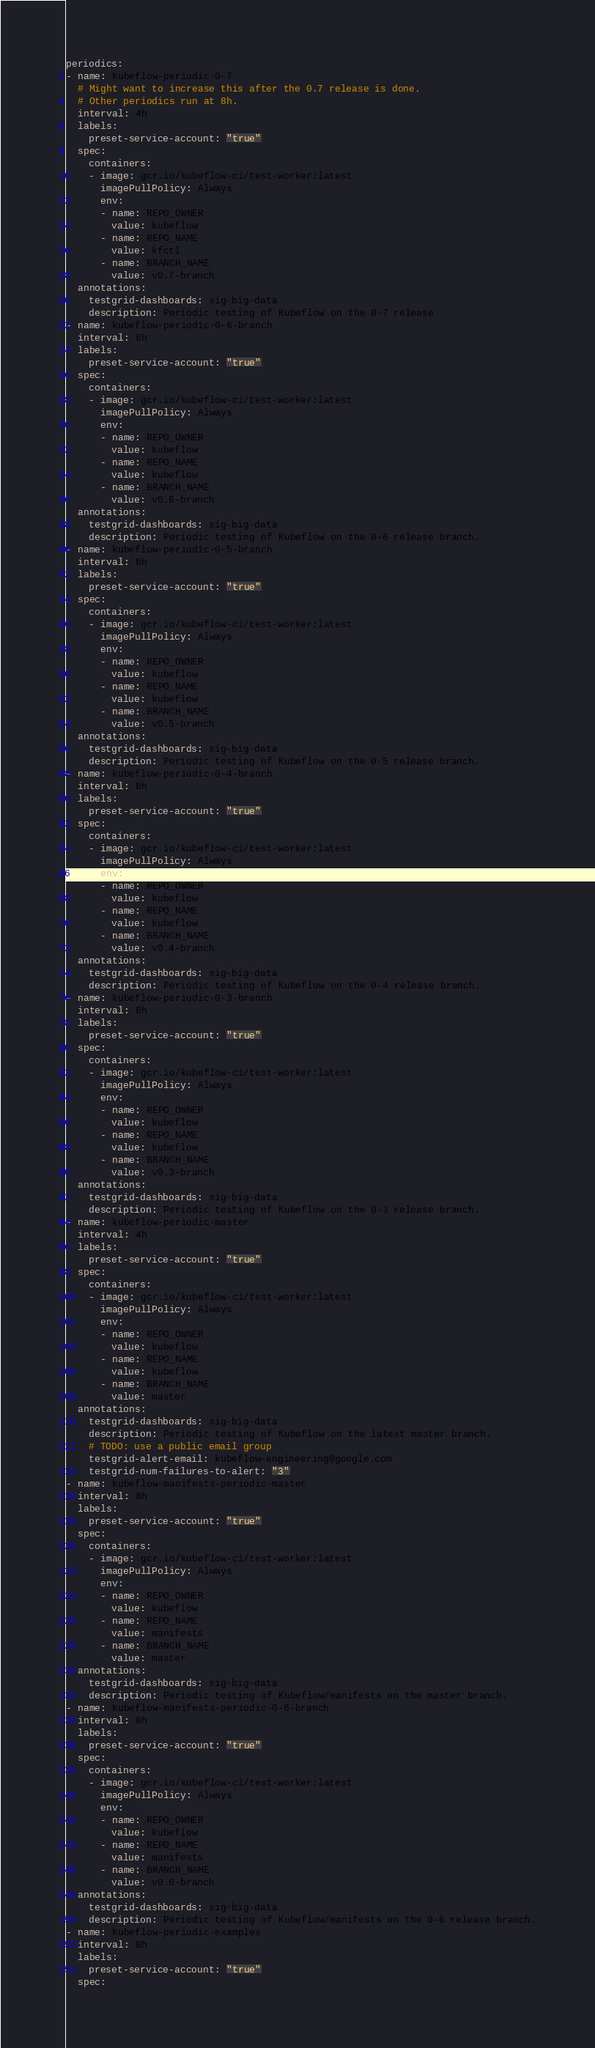<code> <loc_0><loc_0><loc_500><loc_500><_YAML_>periodics:
- name: kubeflow-periodic-0-7
  # Might want to increase this after the 0.7 release is done.
  # Other periodics run at 8h.
  interval: 4h
  labels:
    preset-service-account: "true"
  spec:
    containers:
    - image: gcr.io/kubeflow-ci/test-worker:latest
      imagePullPolicy: Always
      env:
      - name: REPO_OWNER
        value: kubeflow
      - name: REPO_NAME
        value: kfctl
      - name: BRANCH_NAME
        value: v0.7-branch
  annotations:
    testgrid-dashboards: sig-big-data
    description: Periodic testing of Kubeflow on the 0-7 release
- name: kubeflow-periodic-0-6-branch
  interval: 8h
  labels:
    preset-service-account: "true"
  spec:
    containers:
    - image: gcr.io/kubeflow-ci/test-worker:latest
      imagePullPolicy: Always
      env:
      - name: REPO_OWNER
        value: kubeflow
      - name: REPO_NAME
        value: kubeflow
      - name: BRANCH_NAME
        value: v0.6-branch
  annotations:
    testgrid-dashboards: sig-big-data
    description: Periodic testing of Kubeflow on the 0-6 release branch.
- name: kubeflow-periodic-0-5-branch
  interval: 8h
  labels:
    preset-service-account: "true"
  spec:
    containers:
    - image: gcr.io/kubeflow-ci/test-worker:latest
      imagePullPolicy: Always
      env:
      - name: REPO_OWNER
        value: kubeflow
      - name: REPO_NAME
        value: kubeflow
      - name: BRANCH_NAME
        value: v0.5-branch
  annotations:
    testgrid-dashboards: sig-big-data
    description: Periodic testing of Kubeflow on the 0-5 release branch.
- name: kubeflow-periodic-0-4-branch
  interval: 8h
  labels:
    preset-service-account: "true"
  spec:
    containers:
    - image: gcr.io/kubeflow-ci/test-worker:latest
      imagePullPolicy: Always
      env:
      - name: REPO_OWNER
        value: kubeflow
      - name: REPO_NAME
        value: kubeflow
      - name: BRANCH_NAME
        value: v0.4-branch
  annotations:
    testgrid-dashboards: sig-big-data
    description: Periodic testing of Kubeflow on the 0-4 release branch.
- name: kubeflow-periodic-0-3-branch
  interval: 8h
  labels:
    preset-service-account: "true"
  spec:
    containers:
    - image: gcr.io/kubeflow-ci/test-worker:latest
      imagePullPolicy: Always
      env:
      - name: REPO_OWNER
        value: kubeflow
      - name: REPO_NAME
        value: kubeflow
      - name: BRANCH_NAME
        value: v0.3-branch
  annotations:
    testgrid-dashboards: sig-big-data
    description: Periodic testing of Kubeflow on the 0-3 release branch.
- name: kubeflow-periodic-master
  interval: 4h
  labels:
    preset-service-account: "true"
  spec:
    containers:
    - image: gcr.io/kubeflow-ci/test-worker:latest
      imagePullPolicy: Always
      env:
      - name: REPO_OWNER
        value: kubeflow
      - name: REPO_NAME
        value: kubeflow
      - name: BRANCH_NAME
        value: master
  annotations:
    testgrid-dashboards: sig-big-data
    description: Periodic testing of Kubeflow on the latest master branch.
    # TODO: use a public email group
    testgrid-alert-email: kubeflow-engineering@google.com
    testgrid-num-failures-to-alert: "3"
- name: kubeflow-manifests-periodic-master
  interval: 8h
  labels:
    preset-service-account: "true"
  spec:
    containers:
    - image: gcr.io/kubeflow-ci/test-worker:latest
      imagePullPolicy: Always
      env:
      - name: REPO_OWNER
        value: kubeflow
      - name: REPO_NAME
        value: manifests
      - name: BRANCH_NAME
        value: master
  annotations:
    testgrid-dashboards: sig-big-data
    description: Periodic testing of Kubeflow/manifests on the master branch.
- name: kubeflow-manifests-periodic-0-6-branch
  interval: 8h
  labels:
    preset-service-account: "true"
  spec:
    containers:
    - image: gcr.io/kubeflow-ci/test-worker:latest
      imagePullPolicy: Always
      env:
      - name: REPO_OWNER
        value: kubeflow
      - name: REPO_NAME
        value: manifests
      - name: BRANCH_NAME
        value: v0.6-branch
  annotations:
    testgrid-dashboards: sig-big-data
    description: Periodic testing of Kubeflow/manifests on the 0-6 release branch.
- name: kubeflow-periodic-examples
  interval: 8h
  labels:
    preset-service-account: "true"
  spec:</code> 